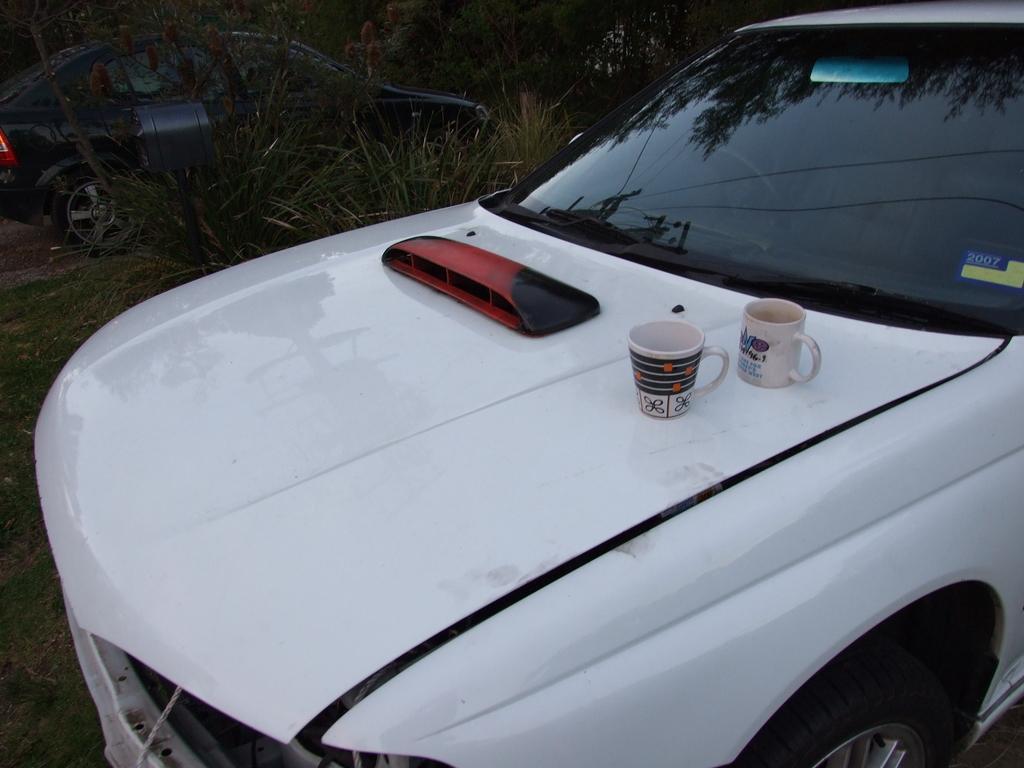Could you give a brief overview of what you see in this image? In this image we can see a few vehicles, among those vehicles we can see some cups and an object on one vehicle, there are some plants and trees. 